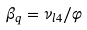<formula> <loc_0><loc_0><loc_500><loc_500>\beta _ { q } = { \nu _ { l 4 } / \varphi }</formula> 